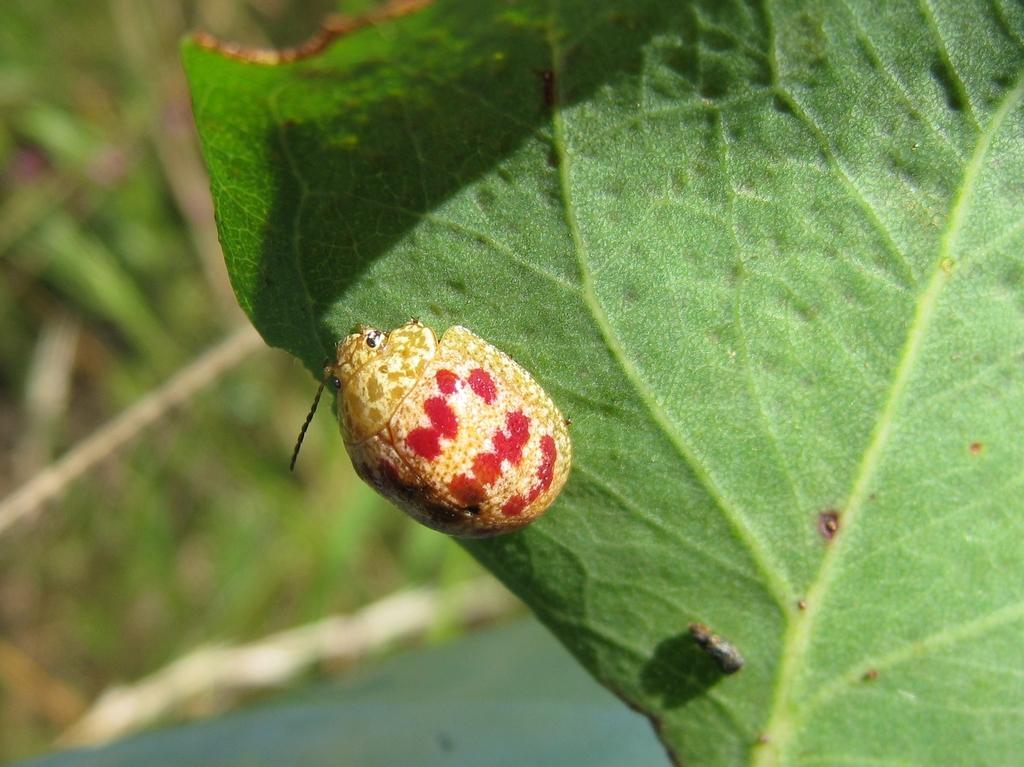What is the main subject of the image? There is a bug in the image. Where is the bug located? The bug is on a leaf. Can you describe the background of the image? The background of the image is blurry. What type of note is the bug holding in the image? There is no note present in the image, and the bug is not holding anything. 